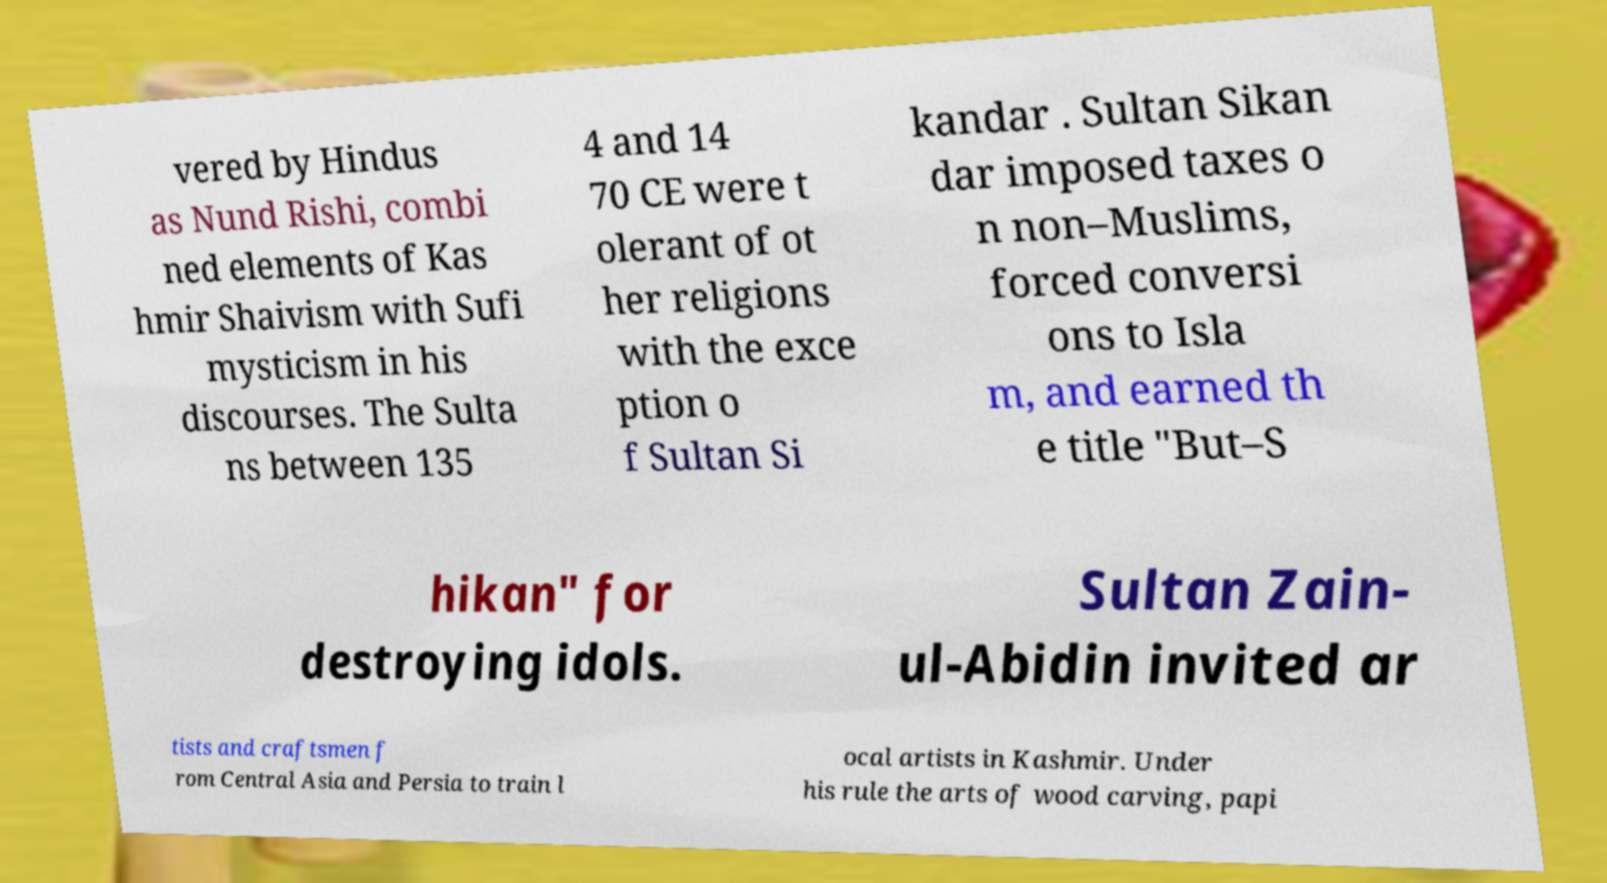For documentation purposes, I need the text within this image transcribed. Could you provide that? vered by Hindus as Nund Rishi, combi ned elements of Kas hmir Shaivism with Sufi mysticism in his discourses. The Sulta ns between 135 4 and 14 70 CE were t olerant of ot her religions with the exce ption o f Sultan Si kandar . Sultan Sikan dar imposed taxes o n non–Muslims, forced conversi ons to Isla m, and earned th e title "But–S hikan" for destroying idols. Sultan Zain- ul-Abidin invited ar tists and craftsmen f rom Central Asia and Persia to train l ocal artists in Kashmir. Under his rule the arts of wood carving, papi 